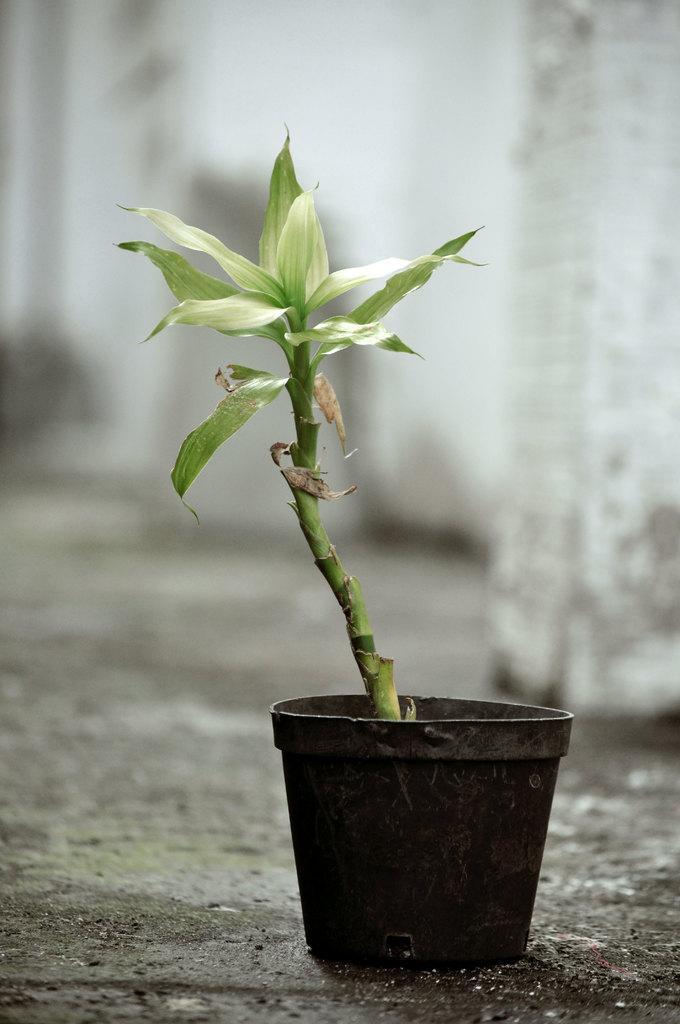Can you describe this image briefly? In this image there is a flower pot on the ground. 